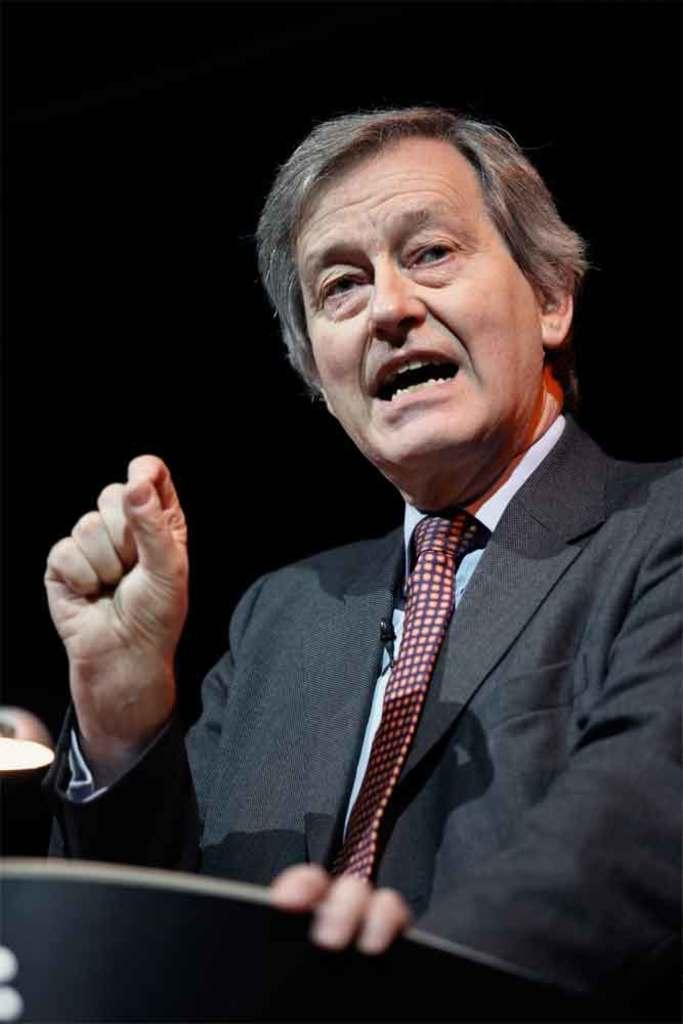What is the main subject of the image? The main subject of the image is a man. What is the man wearing in the image? The man is wearing a suit in the image. What type of pencil can be seen in the man's hand in the image? There is no pencil present in the image; the man is not holding anything. What kind of pest is visible on the man's suit in the image? There is no pest visible on the man's suit in the image. 